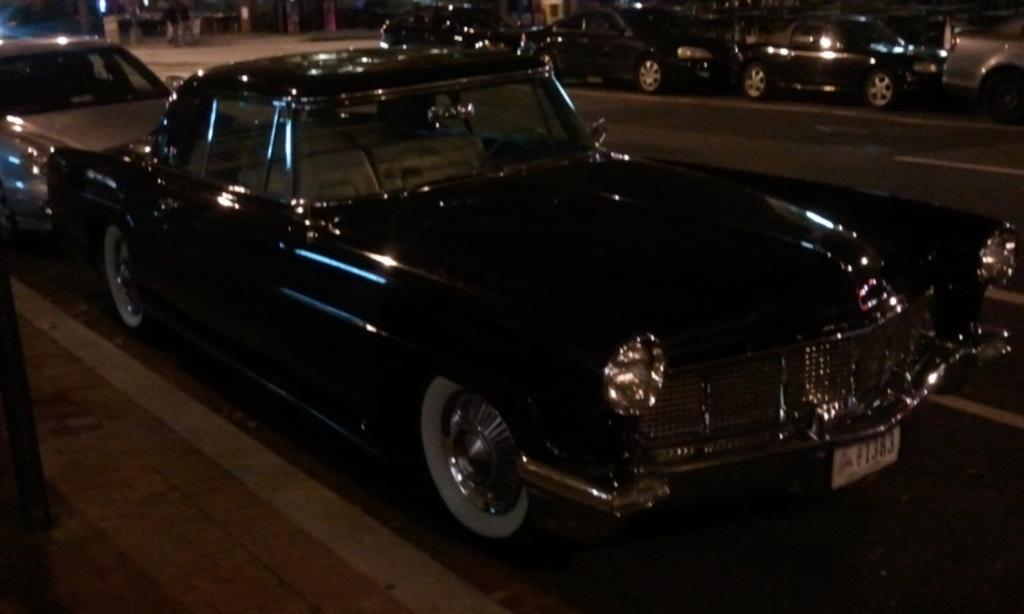What type of vehicles can be seen on the road in the image? There are cars on the road in the image. Is there any pedestrian infrastructure visible in the image? Yes, there is a footpath in the image. What can be seen in the background of the image? There are objects visible in the background of the image. What type of pies are being sold on the sidewalk in the image? There is no mention of pies or a sidewalk in the image; it only features cars on the road and a footpath. 